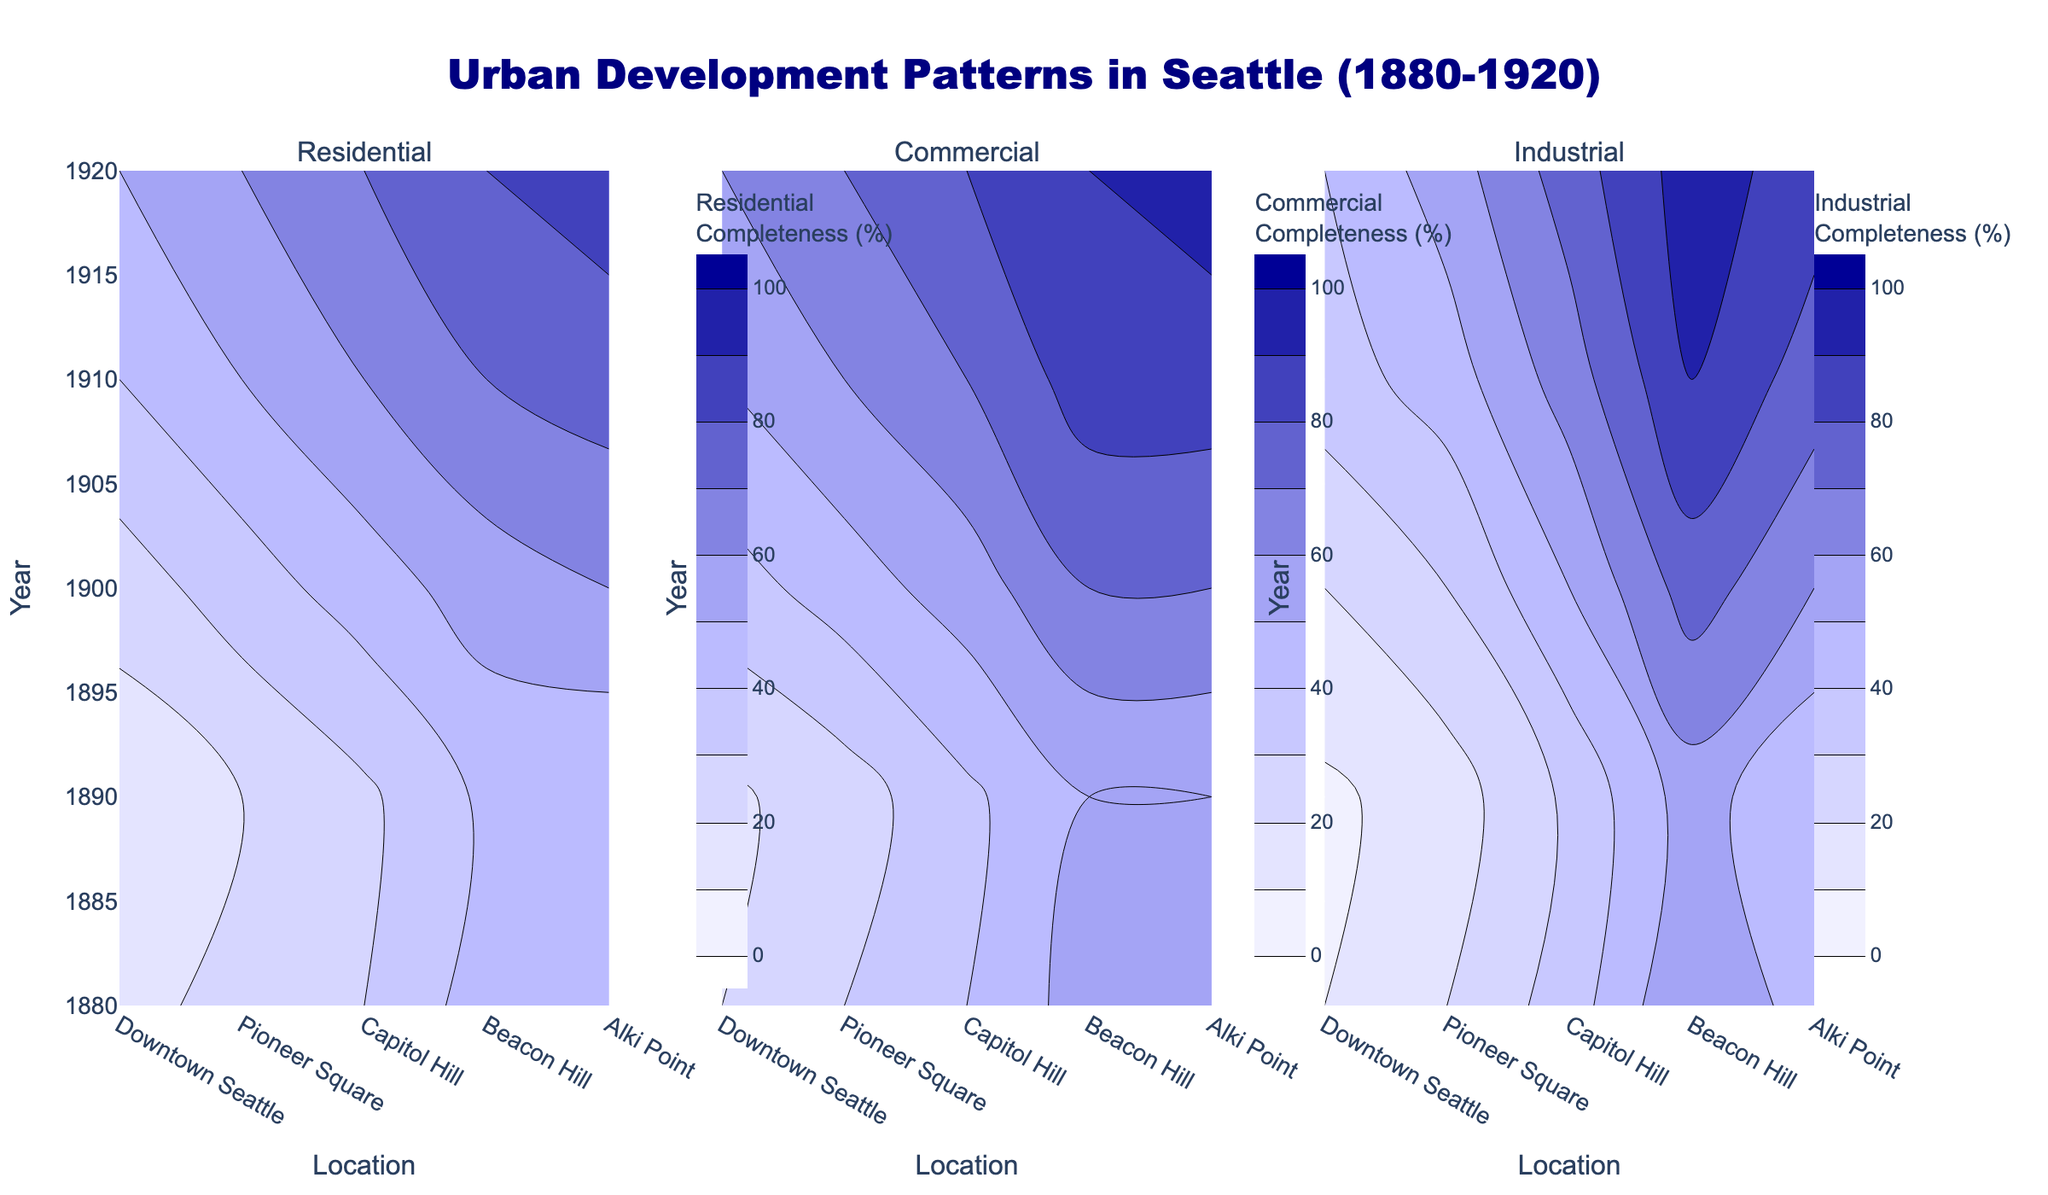What is the title of the figure? The title of the figure is located at the top center of the visual. It is often in a larger and bold font compared to other text elements.
Answer: Urban Development Patterns in Seattle (1880-1920) Which year shows the highest residential development completeness in Downtown Seattle? Look at the leftmost subplot labeled "Residential". Find the highest contour level in "Downtown Seattle" column.
Answer: 1920 Comparing commercial development completeness in Pioneer Square, did it increase or decrease from 1880 to 1890? Look at the middle subplot labeled "Commercial". Find Pioneer Square on the x-axis and compare the values in 1880 and 1890.
Answer: Decrease What color represents a 50% completeness level? Look at the color scale on any of the subplots. Observe the color corresponding to the Completeness (%) label near 50%.
Answer: Light blue How did the industrial development completeness in Alki Point change between 1880 and 1910? Locate Alki Point in the rightmost subplot labeled "Industrial". Compare the contour levels from 1880 to 1910.
Answer: Increased Which location had the most significant change in residential development completeness between 1900 and 1920? Compare the contour levels in the "Residential" subplot for each location between 1900 and 1920 and identify the one with the biggest difference.
Answer: Pioneer Square In which decade did Capitol Hill cross the 50% completeness threshold for commercial development? Look at the middle subplot labeled "Commercial" for Capitol Hill. Identify the decade in which the completeness crosses the 50% contour.
Answer: 1910 Comparing Beacon Hill’s residential development completeness in 1890 and 1900, by how many percentage points did it change? Look at the leftmost subplot labeled "Residential". Locate Beacon Hill and compare its completeness values in 1890 and 1900.
Answer: Increased by 15% Which location shows the slowest growth in industrial development completeness over the entire period? Examine the rightmost subplot labeled "Industrial" for each location. Observe which has the least change in contour levels from 1880 to 1920.
Answer: Alki Point 